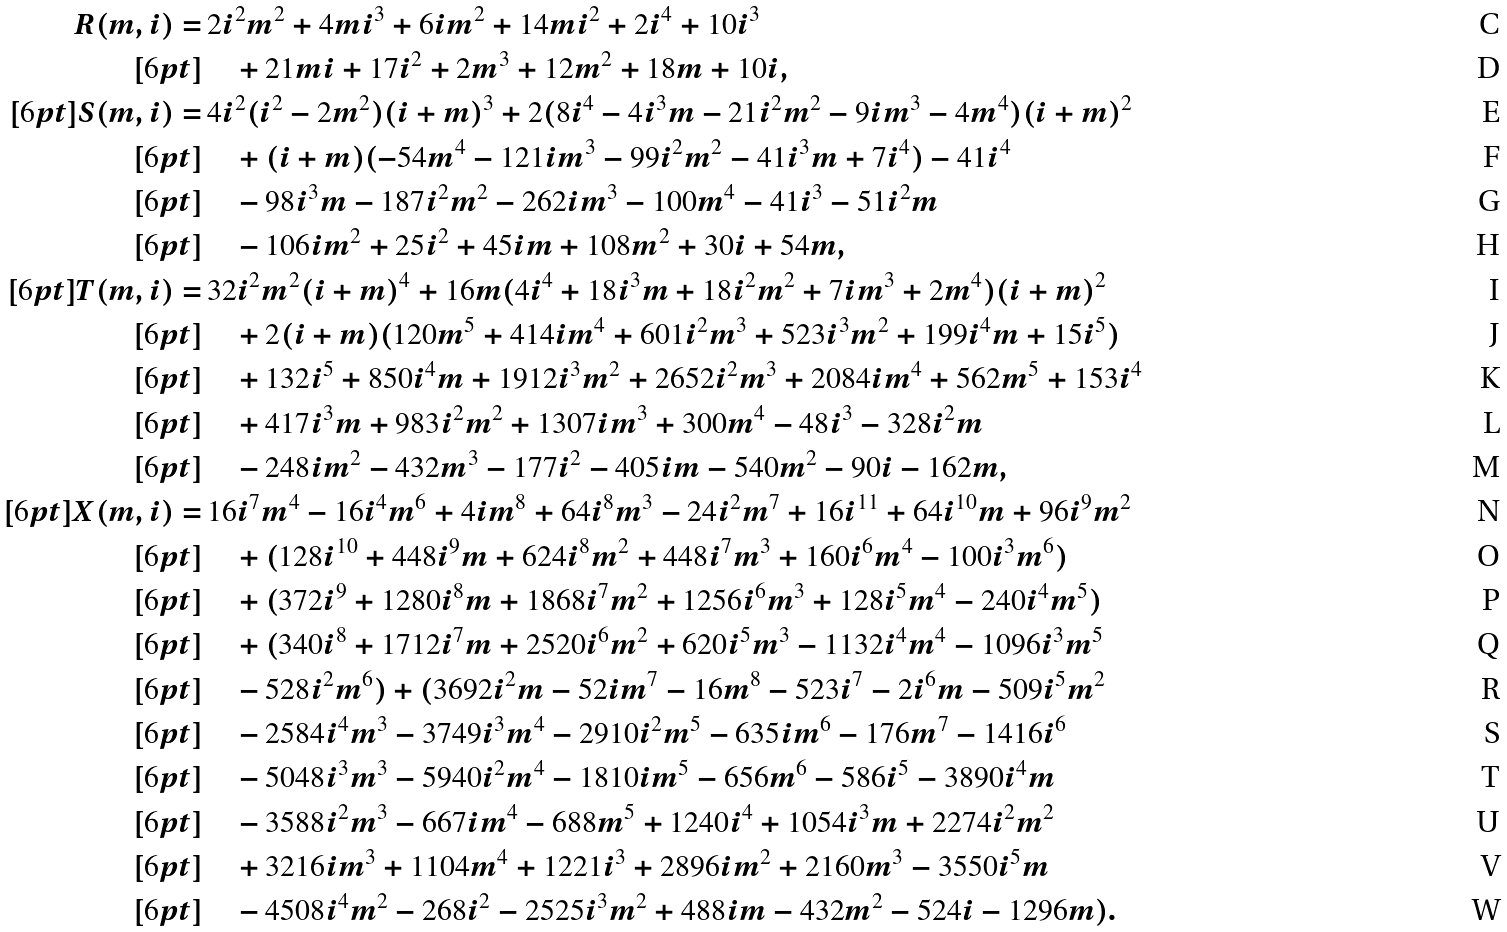<formula> <loc_0><loc_0><loc_500><loc_500>R ( m , i ) = & \, 2 i ^ { 2 } m ^ { 2 } + 4 m i ^ { 3 } + 6 i m ^ { 2 } + 1 4 m i ^ { 2 } + 2 i ^ { 4 } + 1 0 i ^ { 3 } \\ [ 6 p t ] & \quad + 2 1 m i + 1 7 i ^ { 2 } + 2 m ^ { 3 } + 1 2 m ^ { 2 } + 1 8 m + 1 0 i , \\ [ 6 p t ] S ( m , i ) = & \, 4 i ^ { 2 } ( i ^ { 2 } - 2 m ^ { 2 } ) ( i + m ) ^ { 3 } + 2 ( 8 i ^ { 4 } - 4 i ^ { 3 } m - 2 1 i ^ { 2 } m ^ { 2 } - 9 i m ^ { 3 } - 4 m ^ { 4 } ) ( i + m ) ^ { 2 } \\ [ 6 p t ] & \quad + ( i + m ) ( - 5 4 m ^ { 4 } - 1 2 1 i m ^ { 3 } - 9 9 i ^ { 2 } m ^ { 2 } - 4 1 i ^ { 3 } m + 7 i ^ { 4 } ) - 4 1 i ^ { 4 } \\ [ 6 p t ] & \quad - 9 8 i ^ { 3 } m - 1 8 7 i ^ { 2 } m ^ { 2 } - 2 6 2 i m ^ { 3 } - 1 0 0 m ^ { 4 } - 4 1 i ^ { 3 } - 5 1 i ^ { 2 } m \\ [ 6 p t ] & \quad - 1 0 6 i m ^ { 2 } + 2 5 i ^ { 2 } + 4 5 i m + 1 0 8 m ^ { 2 } + 3 0 i + 5 4 m , \\ [ 6 p t ] T ( m , i ) = & \, 3 2 i ^ { 2 } m ^ { 2 } ( i + m ) ^ { 4 } + 1 6 m ( 4 i ^ { 4 } + 1 8 i ^ { 3 } m + 1 8 i ^ { 2 } m ^ { 2 } + 7 i m ^ { 3 } + 2 m ^ { 4 } ) ( i + m ) ^ { 2 } \\ [ 6 p t ] & \quad + 2 ( i + m ) ( 1 2 0 m ^ { 5 } + 4 1 4 i m ^ { 4 } + 6 0 1 i ^ { 2 } m ^ { 3 } + 5 2 3 i ^ { 3 } m ^ { 2 } + 1 9 9 i ^ { 4 } m + 1 5 i ^ { 5 } ) \\ [ 6 p t ] & \quad + 1 3 2 i ^ { 5 } + 8 5 0 i ^ { 4 } m + 1 9 1 2 i ^ { 3 } m ^ { 2 } + 2 6 5 2 i ^ { 2 } m ^ { 3 } + 2 0 8 4 i m ^ { 4 } + 5 6 2 m ^ { 5 } + 1 5 3 i ^ { 4 } \\ [ 6 p t ] & \quad + 4 1 7 i ^ { 3 } m + 9 8 3 i ^ { 2 } m ^ { 2 } + 1 3 0 7 i m ^ { 3 } + 3 0 0 m ^ { 4 } - 4 8 i ^ { 3 } - 3 2 8 i ^ { 2 } m \\ [ 6 p t ] & \quad - 2 4 8 i m ^ { 2 } - 4 3 2 m ^ { 3 } - 1 7 7 i ^ { 2 } - 4 0 5 i m - 5 4 0 m ^ { 2 } - 9 0 i - 1 6 2 m , \\ [ 6 p t ] X ( m , i ) = & \, 1 6 i ^ { 7 } m ^ { 4 } - 1 6 i ^ { 4 } m ^ { 6 } + 4 i m ^ { 8 } + 6 4 i ^ { 8 } m ^ { 3 } - 2 4 i ^ { 2 } m ^ { 7 } + 1 6 i ^ { 1 1 } + 6 4 i ^ { 1 0 } m + 9 6 i ^ { 9 } m ^ { 2 } \\ [ 6 p t ] & \quad + ( 1 2 8 i ^ { 1 0 } + 4 4 8 i ^ { 9 } m + 6 2 4 i ^ { 8 } m ^ { 2 } + 4 4 8 i ^ { 7 } m ^ { 3 } + 1 6 0 i ^ { 6 } m ^ { 4 } - 1 0 0 i ^ { 3 } m ^ { 6 } ) \\ [ 6 p t ] & \quad + ( 3 7 2 i ^ { 9 } + 1 2 8 0 i ^ { 8 } m + 1 8 6 8 i ^ { 7 } m ^ { 2 } + 1 2 5 6 i ^ { 6 } m ^ { 3 } + 1 2 8 i ^ { 5 } m ^ { 4 } - 2 4 0 i ^ { 4 } m ^ { 5 } ) \\ [ 6 p t ] & \quad + ( 3 4 0 i ^ { 8 } + 1 7 1 2 i ^ { 7 } m + 2 5 2 0 i ^ { 6 } m ^ { 2 } + 6 2 0 i ^ { 5 } m ^ { 3 } - 1 1 3 2 i ^ { 4 } m ^ { 4 } - 1 0 9 6 i ^ { 3 } m ^ { 5 } \\ [ 6 p t ] & \quad - 5 2 8 i ^ { 2 } m ^ { 6 } ) + ( 3 6 9 2 i ^ { 2 } m - 5 2 i m ^ { 7 } - 1 6 m ^ { 8 } - 5 2 3 i ^ { 7 } - 2 i ^ { 6 } m - 5 0 9 i ^ { 5 } m ^ { 2 } \\ [ 6 p t ] & \quad - 2 5 8 4 i ^ { 4 } m ^ { 3 } - 3 7 4 9 i ^ { 3 } m ^ { 4 } - 2 9 1 0 i ^ { 2 } m ^ { 5 } - 6 3 5 i m ^ { 6 } - 1 7 6 m ^ { 7 } - 1 4 1 6 i ^ { 6 } \\ [ 6 p t ] & \quad - 5 0 4 8 i ^ { 3 } m ^ { 3 } - 5 9 4 0 i ^ { 2 } m ^ { 4 } - 1 8 1 0 i m ^ { 5 } - 6 5 6 m ^ { 6 } - 5 8 6 i ^ { 5 } - 3 8 9 0 i ^ { 4 } m \\ [ 6 p t ] & \quad - 3 5 8 8 i ^ { 2 } m ^ { 3 } - 6 6 7 i m ^ { 4 } - 6 8 8 m ^ { 5 } + 1 2 4 0 i ^ { 4 } + 1 0 5 4 i ^ { 3 } m + 2 2 7 4 i ^ { 2 } m ^ { 2 } \\ [ 6 p t ] & \quad + 3 2 1 6 i m ^ { 3 } + 1 1 0 4 m ^ { 4 } + 1 2 2 1 i ^ { 3 } + 2 8 9 6 i m ^ { 2 } + 2 1 6 0 m ^ { 3 } - 3 5 5 0 i ^ { 5 } m \\ [ 6 p t ] & \quad - 4 5 0 8 i ^ { 4 } m ^ { 2 } - 2 6 8 i ^ { 2 } - 2 5 2 5 i ^ { 3 } m ^ { 2 } + 4 8 8 i m - 4 3 2 m ^ { 2 } - 5 2 4 i - 1 2 9 6 m ) .</formula> 